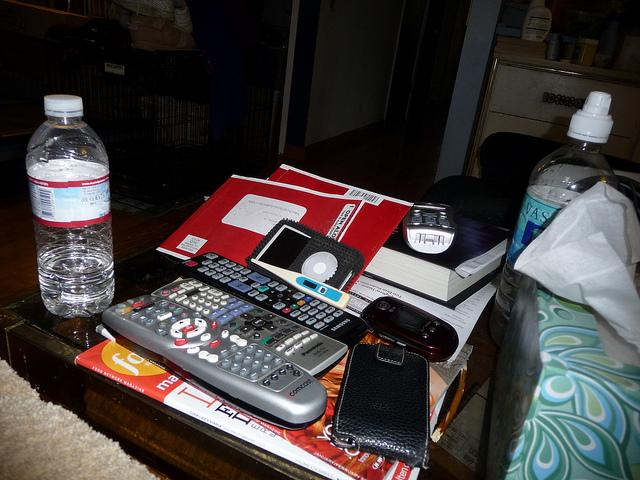The red envelopes on the table indicate that there is what electronic device in the room? dvd player 